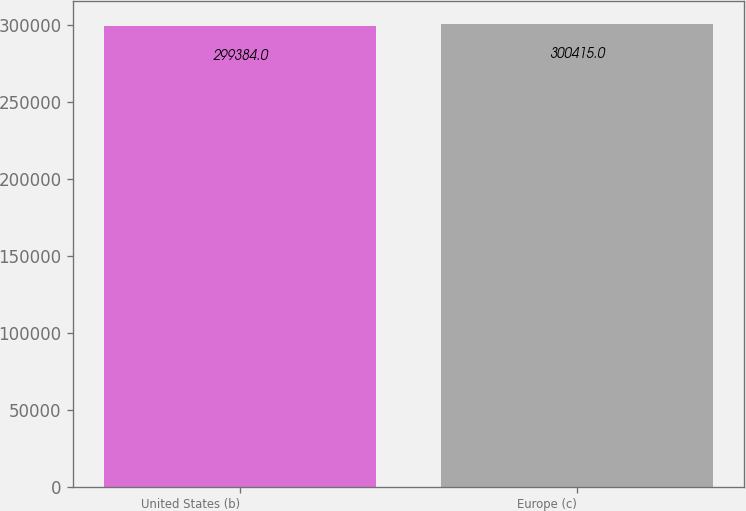Convert chart to OTSL. <chart><loc_0><loc_0><loc_500><loc_500><bar_chart><fcel>United States (b)<fcel>Europe (c)<nl><fcel>299384<fcel>300415<nl></chart> 